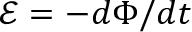Convert formula to latex. <formula><loc_0><loc_0><loc_500><loc_500>\mathcal { E } = - d \Phi / d t</formula> 